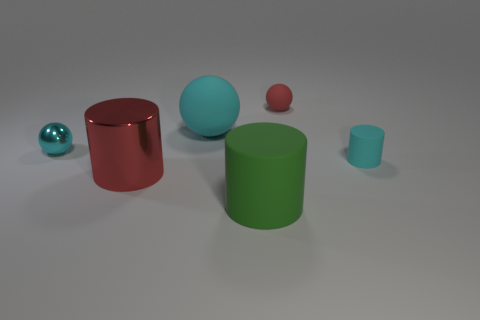Subtract all red balls. How many balls are left? 2 Add 1 gray rubber cylinders. How many objects exist? 7 Subtract 2 cylinders. How many cylinders are left? 1 Subtract all red balls. How many balls are left? 2 Subtract all yellow cylinders. How many blue balls are left? 0 Add 6 large green matte objects. How many large green matte objects exist? 7 Subtract 1 cyan cylinders. How many objects are left? 5 Subtract all brown cylinders. Subtract all green blocks. How many cylinders are left? 3 Subtract all cylinders. Subtract all large things. How many objects are left? 0 Add 5 tiny metal objects. How many tiny metal objects are left? 6 